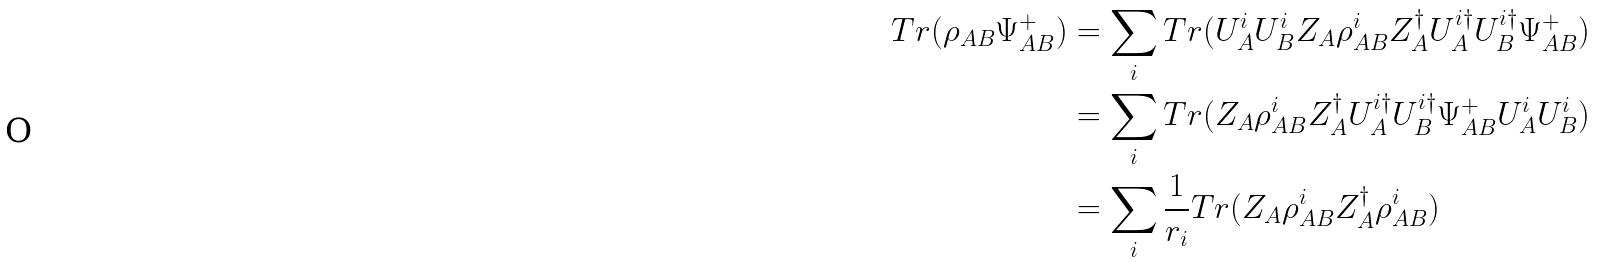Convert formula to latex. <formula><loc_0><loc_0><loc_500><loc_500>T r ( \rho _ { A B } \Psi ^ { + } _ { A B } ) & = \sum _ { i } T r ( U _ { A } ^ { i } U _ { B } ^ { i } Z _ { A } \rho _ { A B } ^ { i } Z _ { A } ^ { \dag } U _ { A } ^ { i \dag } U _ { B } ^ { i \dag } \Psi ^ { + } _ { A B } ) \\ & = \sum _ { i } T r ( Z _ { A } \rho _ { A B } ^ { i } Z _ { A } ^ { \dag } U _ { A } ^ { i \dag } U _ { B } ^ { i \dag } \Psi ^ { + } _ { A B } U _ { A } ^ { i } U _ { B } ^ { i } ) \\ & = \sum _ { i } \frac { 1 } { r _ { i } } T r ( Z _ { A } \rho _ { A B } ^ { i } Z _ { A } ^ { \dag } \rho _ { A B } ^ { i } )</formula> 